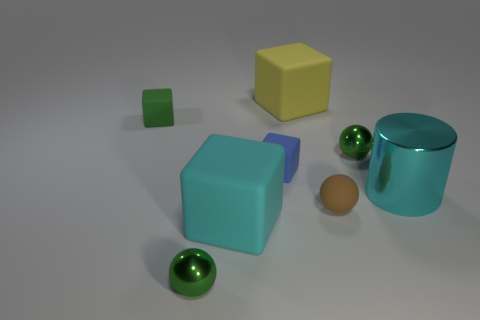What shape is the small green metal object that is on the left side of the large yellow rubber object? sphere 